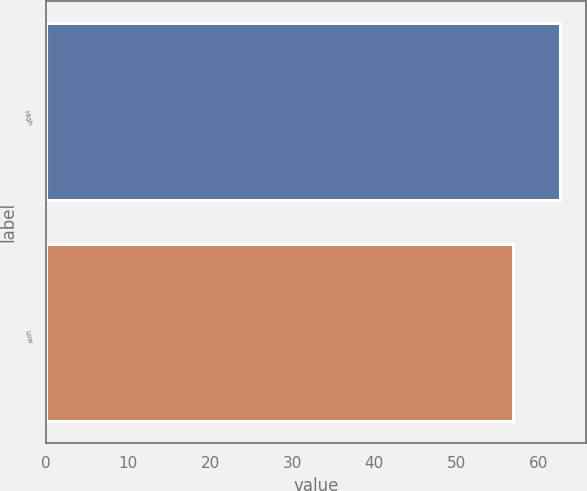Convert chart. <chart><loc_0><loc_0><loc_500><loc_500><bar_chart><fcel>High<fcel>Low<nl><fcel>62.68<fcel>56.84<nl></chart> 